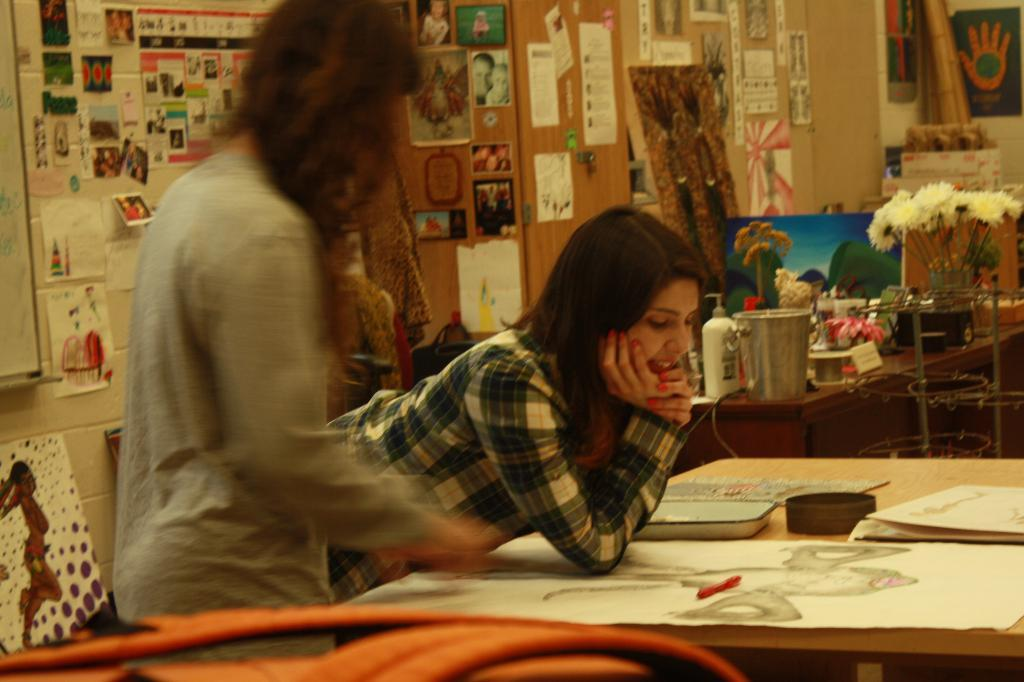How many women are present in the image? There are two women in the image. What are the positions of the women in the image? One woman is standing, and the other is laying on the table. What is the woman on the table doing? The woman on the table has charts in front of her. What can be seen on the table in the room? There are different items on the table in the room. What type of kite is the woman on the table flying in the image? There is no kite present in the image; the woman on the table has charts in front of her. 